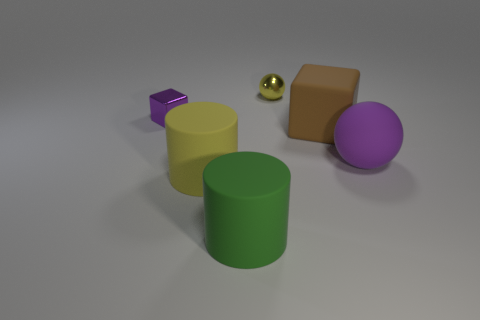What color is the sphere that is behind the purple thing in front of the big brown block?
Offer a very short reply. Yellow. Is there a green matte object?
Your response must be concise. Yes. The rubber object that is behind the yellow rubber cylinder and in front of the big brown rubber cube is what color?
Provide a short and direct response. Purple. Do the thing that is behind the small purple thing and the ball that is in front of the metal ball have the same size?
Your answer should be compact. No. What number of other things are there of the same size as the yellow shiny ball?
Keep it short and to the point. 1. What number of large green rubber cylinders are in front of the purple object behind the big purple matte object?
Provide a short and direct response. 1. Are there fewer green matte cylinders that are in front of the metallic cube than brown objects?
Your answer should be compact. No. What is the shape of the purple object that is to the left of the yellow object behind the yellow object left of the small metallic ball?
Offer a very short reply. Cube. Do the big purple thing and the small yellow metallic thing have the same shape?
Make the answer very short. Yes. How many other things are there of the same shape as the large purple thing?
Offer a very short reply. 1. 